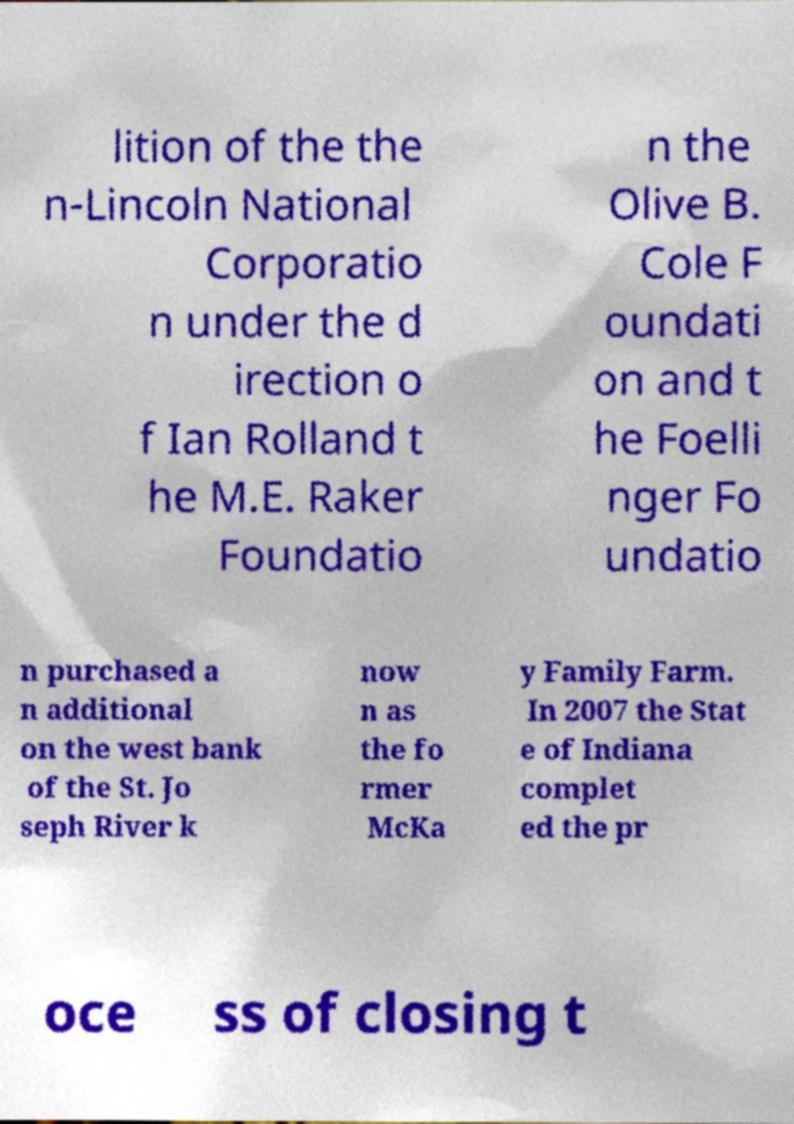What messages or text are displayed in this image? I need them in a readable, typed format. lition of the the n-Lincoln National Corporatio n under the d irection o f Ian Rolland t he M.E. Raker Foundatio n the Olive B. Cole F oundati on and t he Foelli nger Fo undatio n purchased a n additional on the west bank of the St. Jo seph River k now n as the fo rmer McKa y Family Farm. In 2007 the Stat e of Indiana complet ed the pr oce ss of closing t 